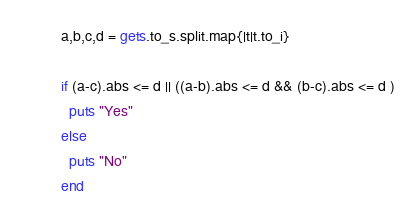<code> <loc_0><loc_0><loc_500><loc_500><_Crystal_>a,b,c,d = gets.to_s.split.map{|t|t.to_i}

if (a-c).abs <= d || ((a-b).abs <= d && (b-c).abs <= d )
  puts "Yes"
else
  puts "No"
end</code> 